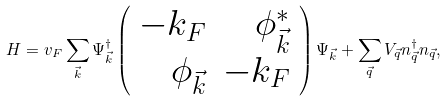<formula> <loc_0><loc_0><loc_500><loc_500>H = v _ { F } \sum _ { \vec { k } } \Psi _ { \vec { k } } ^ { \dagger } \left ( \begin{array} { r r } - k _ { F } & \phi _ { \vec { k } } ^ { * } \\ \phi _ { \vec { k } } & - k _ { F } \end{array} \right ) \Psi _ { \vec { k } } + \sum _ { \vec { q } } V _ { \vec { q } } n _ { \vec { q } } ^ { \dagger } n _ { \vec { q } } ,</formula> 